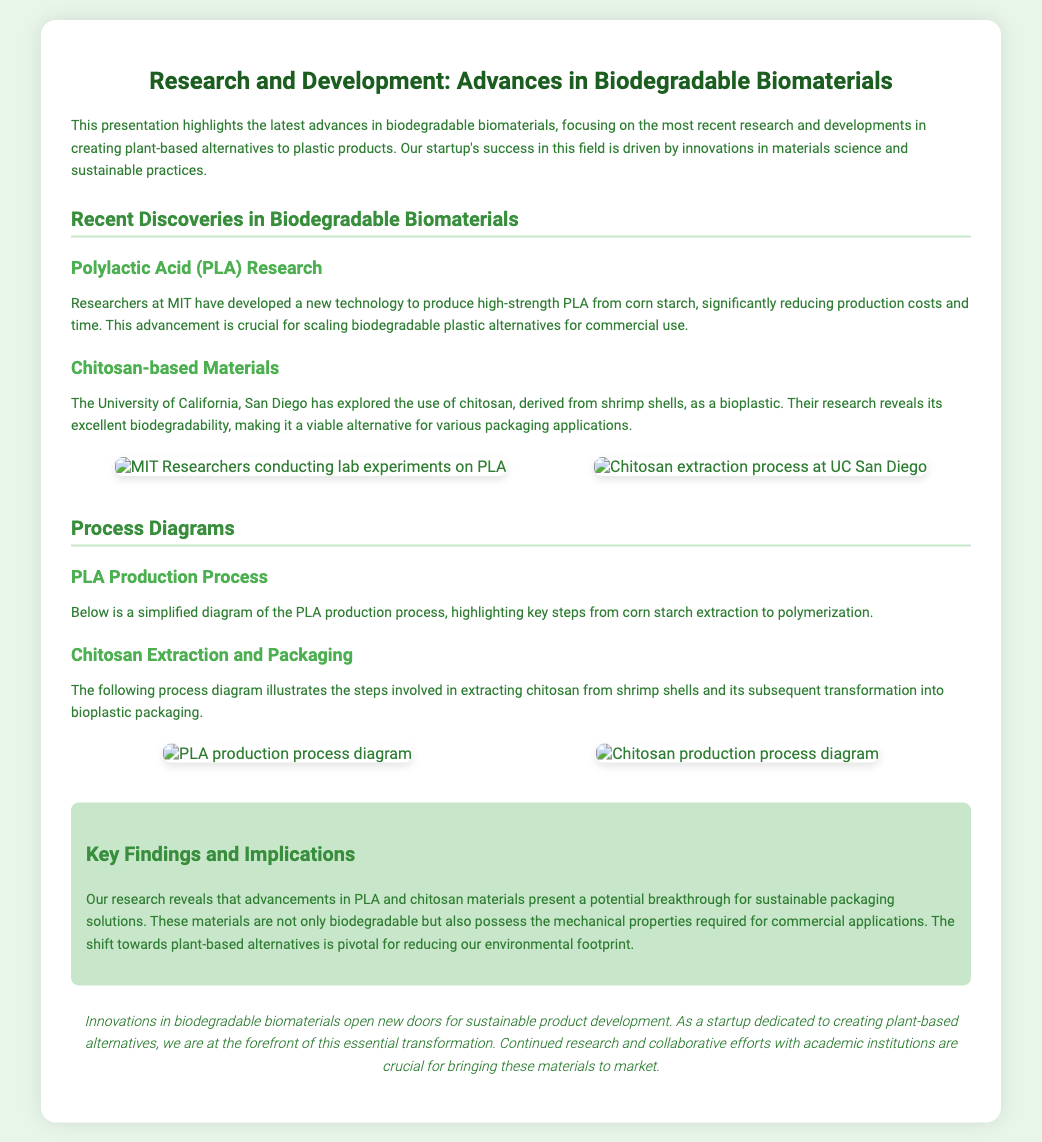what is the title of the presentation? The title is prominently displayed at the top of the document, indicating the main topic being presented.
Answer: Research and Development: Advances in Biodegradable Biomaterials who developed high-strength PLA from corn starch? The presentation mentions the institution responsible for this advancement, highlighting their role in biodegradable materials research.
Answer: MIT what is chitosan derived from? The source of chitosan is specified in the section discussing its properties, providing context on its raw material origin.
Answer: shrimp shells which university researched chitosan-based materials? This question pertains to the academic institution involved in exploring new bioplastic materials, emphasizing collaboration in this field.
Answer: University of California, San Diego what type of diagrams are presented in the document? The document contains visuals representing processes that illustrate key steps in the production methods discussed.
Answer: process diagrams how does the presentation describe the biodegradability of the materials? The presentation touches on the characteristics of the highlighted materials through comparisons to conventional plastics, providing insight into their sustainability.
Answer: excellent what are the implications of the research findings? The document summarizes the broader significance of the advances in materials highlighted, addressing environmental considerations.
Answer: sustainable packaging solutions what follows the PLA production process section? The structure of the presentation includes a discussion of another specific material, indicating a continued exploration of alternatives.
Answer: Chitosan Extraction and Packaging what is the focus of the key findings section? This section emphasizes the primary insights gleaned from the research, summarizing the overall impact of the materials discussed.
Answer: biodegradable and mechanical properties 